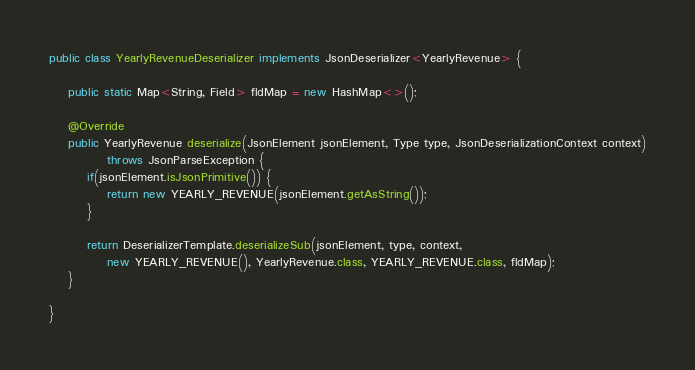Convert code to text. <code><loc_0><loc_0><loc_500><loc_500><_Java_>public class YearlyRevenueDeserializer implements JsonDeserializer<YearlyRevenue> {

	public static Map<String, Field> fldMap = new HashMap<>();

	@Override
	public YearlyRevenue deserialize(JsonElement jsonElement, Type type, JsonDeserializationContext context)
			throws JsonParseException {
		if(jsonElement.isJsonPrimitive()) {
			return new YEARLY_REVENUE(jsonElement.getAsString());
		}

		return DeserializerTemplate.deserializeSub(jsonElement, type, context,
			new YEARLY_REVENUE(), YearlyRevenue.class, YEARLY_REVENUE.class, fldMap);
	}

}
</code> 